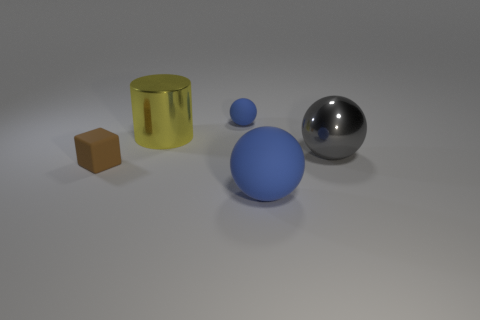Is there a light source within the scene, and if so, how can you determine its direction? Yes, there appears to be a single light source illuminating the scene. The direction of the light can be inferred from the shadows cast by the objects. They are elongated and fall predominantly towards the bottom right of the image, suggesting that the light source is situated towards the upper left, off-frame. Additionally, the highlights and reflections on the objects, especially on the reflective sphere, confirm the light source's direction from the upper left. 